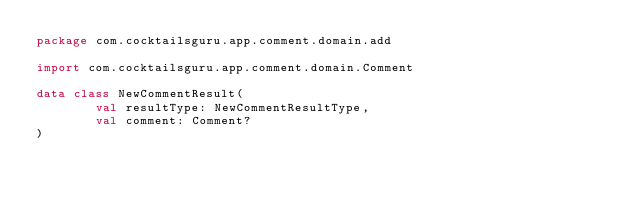Convert code to text. <code><loc_0><loc_0><loc_500><loc_500><_Kotlin_>package com.cocktailsguru.app.comment.domain.add

import com.cocktailsguru.app.comment.domain.Comment

data class NewCommentResult(
        val resultType: NewCommentResultType,
        val comment: Comment?
)</code> 